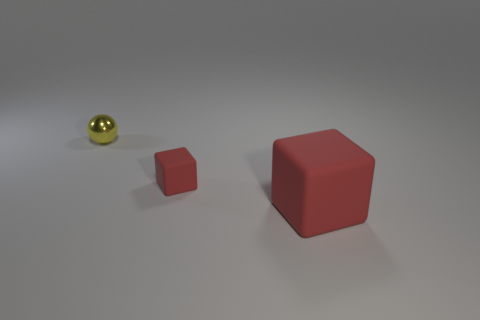What might be the use of these objects in a real-world setting? The objects in the image could serve both educational and practical purposes. The cubes might be used as teaching tools to illustrate geometric concepts, while the sphere could be a part of a set of decorative items or used in various ball games if it's made of a bouncy material. All objects can also be used as models for graphical renderings or as part of a designer's toolkit for conceptual visualization.  How about the size relation between these objects? The size relationship among the objects is clear: there is a large red cube, a smaller red cube, and a small golden sphere. The smaller cube and the golden sphere appear to be of similar size, and this could be used to visually demonstrate the concept of scale or proportion in a composition or design layout. 